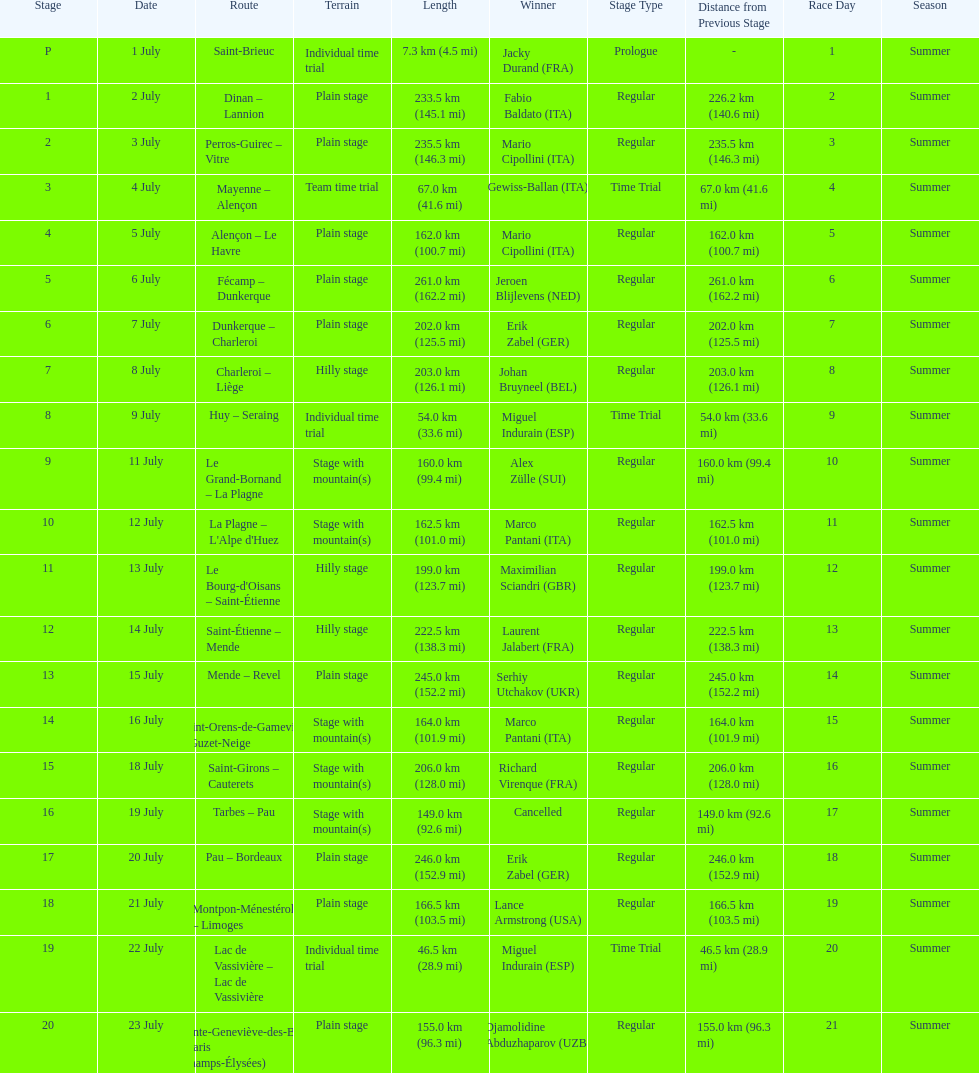Which country had more stage-winners than any other country? Italy. Could you help me parse every detail presented in this table? {'header': ['Stage', 'Date', 'Route', 'Terrain', 'Length', 'Winner', 'Stage Type', 'Distance from Previous Stage', 'Race Day', 'Season'], 'rows': [['P', '1 July', 'Saint-Brieuc', 'Individual time trial', '7.3\xa0km (4.5\xa0mi)', 'Jacky Durand\xa0(FRA)', 'Prologue', '-', '1', 'Summer'], ['1', '2 July', 'Dinan – Lannion', 'Plain stage', '233.5\xa0km (145.1\xa0mi)', 'Fabio Baldato\xa0(ITA)', 'Regular', '226.2 km (140.6 mi)', '2', 'Summer'], ['2', '3 July', 'Perros-Guirec – Vitre', 'Plain stage', '235.5\xa0km (146.3\xa0mi)', 'Mario Cipollini\xa0(ITA)', 'Regular', '235.5 km (146.3 mi)', '3', 'Summer'], ['3', '4 July', 'Mayenne – Alençon', 'Team time trial', '67.0\xa0km (41.6\xa0mi)', 'Gewiss-Ballan\xa0(ITA)', 'Time Trial', '67.0 km (41.6 mi)', '4', 'Summer'], ['4', '5 July', 'Alençon – Le Havre', 'Plain stage', '162.0\xa0km (100.7\xa0mi)', 'Mario Cipollini\xa0(ITA)', 'Regular', '162.0 km (100.7 mi)', '5', 'Summer'], ['5', '6 July', 'Fécamp – Dunkerque', 'Plain stage', '261.0\xa0km (162.2\xa0mi)', 'Jeroen Blijlevens\xa0(NED)', 'Regular', '261.0 km (162.2 mi)', '6', 'Summer'], ['6', '7 July', 'Dunkerque – Charleroi', 'Plain stage', '202.0\xa0km (125.5\xa0mi)', 'Erik Zabel\xa0(GER)', 'Regular', '202.0 km (125.5 mi)', '7', 'Summer'], ['7', '8 July', 'Charleroi – Liège', 'Hilly stage', '203.0\xa0km (126.1\xa0mi)', 'Johan Bruyneel\xa0(BEL)', 'Regular', '203.0 km (126.1 mi)', '8', 'Summer'], ['8', '9 July', 'Huy – Seraing', 'Individual time trial', '54.0\xa0km (33.6\xa0mi)', 'Miguel Indurain\xa0(ESP)', 'Time Trial', '54.0 km (33.6 mi)', '9', 'Summer'], ['9', '11 July', 'Le Grand-Bornand – La Plagne', 'Stage with mountain(s)', '160.0\xa0km (99.4\xa0mi)', 'Alex Zülle\xa0(SUI)', 'Regular', '160.0 km (99.4 mi)', '10', 'Summer'], ['10', '12 July', "La Plagne – L'Alpe d'Huez", 'Stage with mountain(s)', '162.5\xa0km (101.0\xa0mi)', 'Marco Pantani\xa0(ITA)', 'Regular', '162.5 km (101.0 mi)', '11', 'Summer'], ['11', '13 July', "Le Bourg-d'Oisans – Saint-Étienne", 'Hilly stage', '199.0\xa0km (123.7\xa0mi)', 'Maximilian Sciandri\xa0(GBR)', 'Regular', '199.0 km (123.7 mi)', '12', 'Summer'], ['12', '14 July', 'Saint-Étienne – Mende', 'Hilly stage', '222.5\xa0km (138.3\xa0mi)', 'Laurent Jalabert\xa0(FRA)', 'Regular', '222.5 km (138.3 mi)', '13', 'Summer'], ['13', '15 July', 'Mende – Revel', 'Plain stage', '245.0\xa0km (152.2\xa0mi)', 'Serhiy Utchakov\xa0(UKR)', 'Regular', '245.0 km (152.2 mi)', '14', 'Summer'], ['14', '16 July', 'Saint-Orens-de-Gameville – Guzet-Neige', 'Stage with mountain(s)', '164.0\xa0km (101.9\xa0mi)', 'Marco Pantani\xa0(ITA)', 'Regular', '164.0 km (101.9 mi)', '15', 'Summer'], ['15', '18 July', 'Saint-Girons – Cauterets', 'Stage with mountain(s)', '206.0\xa0km (128.0\xa0mi)', 'Richard Virenque\xa0(FRA)', 'Regular', '206.0 km (128.0 mi)', '16', 'Summer'], ['16', '19 July', 'Tarbes – Pau', 'Stage with mountain(s)', '149.0\xa0km (92.6\xa0mi)', 'Cancelled', 'Regular', '149.0 km (92.6 mi)', '17', 'Summer'], ['17', '20 July', 'Pau – Bordeaux', 'Plain stage', '246.0\xa0km (152.9\xa0mi)', 'Erik Zabel\xa0(GER)', 'Regular', '246.0 km (152.9 mi)', '18', 'Summer'], ['18', '21 July', 'Montpon-Ménestérol – Limoges', 'Plain stage', '166.5\xa0km (103.5\xa0mi)', 'Lance Armstrong\xa0(USA)', 'Regular', '166.5 km (103.5 mi)', '19', 'Summer'], ['19', '22 July', 'Lac de Vassivière – Lac de Vassivière', 'Individual time trial', '46.5\xa0km (28.9\xa0mi)', 'Miguel Indurain\xa0(ESP)', 'Time Trial', '46.5 km (28.9 mi)', '20', 'Summer'], ['20', '23 July', 'Sainte-Geneviève-des-Bois – Paris (Champs-Élysées)', 'Plain stage', '155.0\xa0km (96.3\xa0mi)', 'Djamolidine Abduzhaparov\xa0(UZB)', 'Regular', '155.0 km (96.3 mi)', '21', 'Summer']]} 